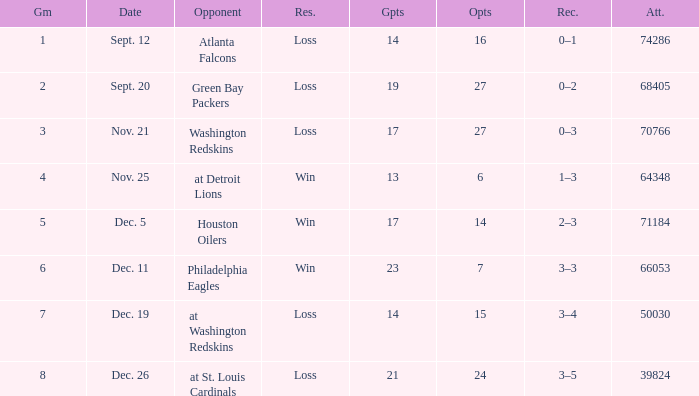What is the record when the opponent is washington redskins? 0–3. 